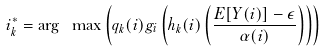<formula> <loc_0><loc_0><loc_500><loc_500>i ^ { * } _ { k } = \arg \ \max \left ( q _ { k } ( i ) g _ { i } \left ( h _ { k } ( i ) \left ( \frac { E [ Y ( i ) ] - \epsilon } { \alpha ( i ) } \right ) \right ) \right )</formula> 